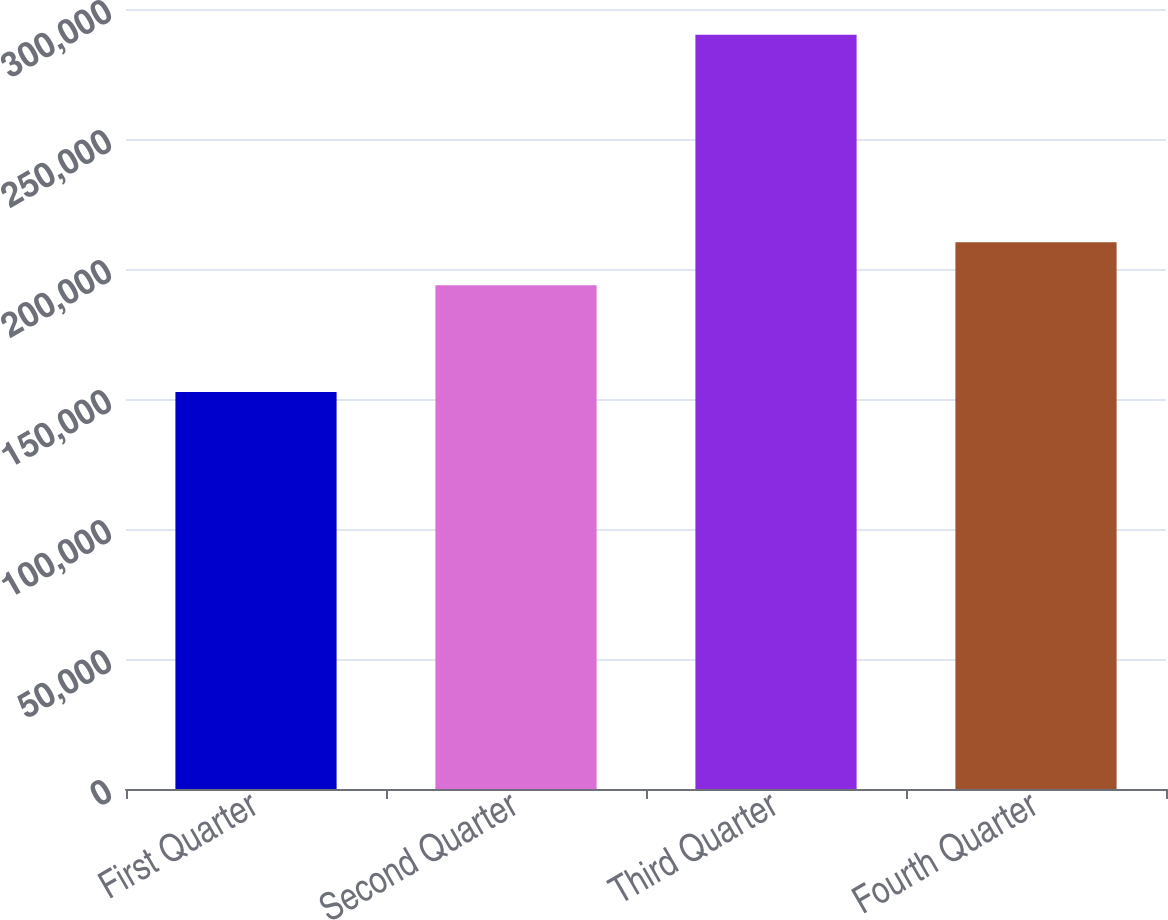<chart> <loc_0><loc_0><loc_500><loc_500><bar_chart><fcel>First Quarter<fcel>Second Quarter<fcel>Third Quarter<fcel>Fourth Quarter<nl><fcel>152648<fcel>193779<fcel>290089<fcel>210325<nl></chart> 